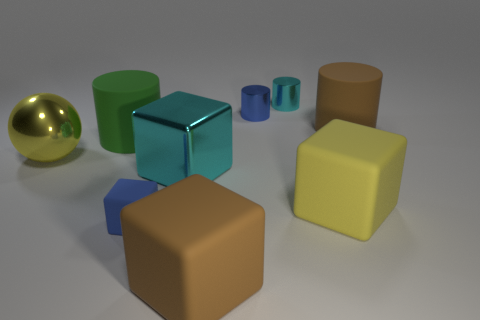There is a blue cylinder; are there any blue objects to the left of it?
Provide a short and direct response. Yes. There is a blue object that is the same shape as the large yellow matte thing; what size is it?
Give a very brief answer. Small. Is there any other thing that is the same size as the green cylinder?
Offer a terse response. Yes. Is the shape of the tiny cyan shiny object the same as the green rubber thing?
Make the answer very short. Yes. How big is the cyan cube to the left of the brown thing behind the ball?
Your response must be concise. Large. What color is the large shiny object that is the same shape as the blue matte object?
Your answer should be compact. Cyan. What number of rubber cubes are the same color as the large metal ball?
Give a very brief answer. 1. The cyan cylinder is what size?
Offer a very short reply. Small. Do the green object and the sphere have the same size?
Make the answer very short. Yes. The cylinder that is both left of the large yellow cube and in front of the small blue cylinder is what color?
Your answer should be compact. Green. 